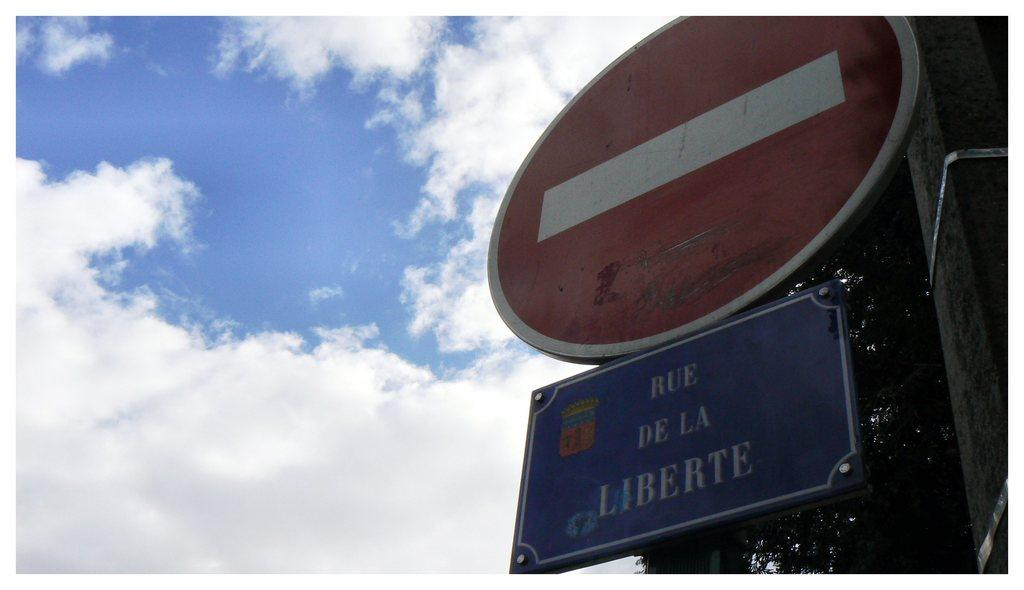What can be seen in the sky in the image? The sky with clouds is visible in the image. What object is present in the image that is typically used for supporting or marking a location? There is a pole in the image. What type of vegetation is visible in the image? There are trees in the image. What type of signage is present in the image? Sign boards are present in the image. What type of decision can be seen being made by the ocean in the image? There is no ocean present in the image, so it is not possible to determine any decisions being made by the ocean. 